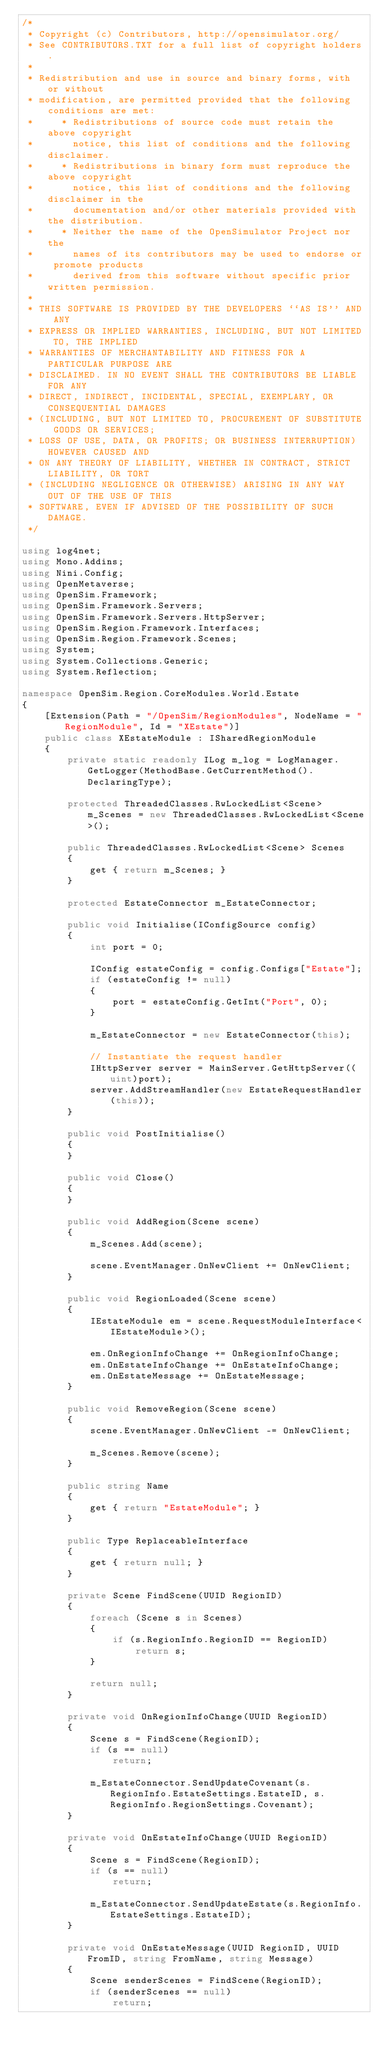<code> <loc_0><loc_0><loc_500><loc_500><_C#_>/*
 * Copyright (c) Contributors, http://opensimulator.org/
 * See CONTRIBUTORS.TXT for a full list of copyright holders.
 *
 * Redistribution and use in source and binary forms, with or without
 * modification, are permitted provided that the following conditions are met:
 *     * Redistributions of source code must retain the above copyright
 *       notice, this list of conditions and the following disclaimer.
 *     * Redistributions in binary form must reproduce the above copyright
 *       notice, this list of conditions and the following disclaimer in the
 *       documentation and/or other materials provided with the distribution.
 *     * Neither the name of the OpenSimulator Project nor the
 *       names of its contributors may be used to endorse or promote products
 *       derived from this software without specific prior written permission.
 *
 * THIS SOFTWARE IS PROVIDED BY THE DEVELOPERS ``AS IS'' AND ANY
 * EXPRESS OR IMPLIED WARRANTIES, INCLUDING, BUT NOT LIMITED TO, THE IMPLIED
 * WARRANTIES OF MERCHANTABILITY AND FITNESS FOR A PARTICULAR PURPOSE ARE
 * DISCLAIMED. IN NO EVENT SHALL THE CONTRIBUTORS BE LIABLE FOR ANY
 * DIRECT, INDIRECT, INCIDENTAL, SPECIAL, EXEMPLARY, OR CONSEQUENTIAL DAMAGES
 * (INCLUDING, BUT NOT LIMITED TO, PROCUREMENT OF SUBSTITUTE GOODS OR SERVICES;
 * LOSS OF USE, DATA, OR PROFITS; OR BUSINESS INTERRUPTION) HOWEVER CAUSED AND
 * ON ANY THEORY OF LIABILITY, WHETHER IN CONTRACT, STRICT LIABILITY, OR TORT
 * (INCLUDING NEGLIGENCE OR OTHERWISE) ARISING IN ANY WAY OUT OF THE USE OF THIS
 * SOFTWARE, EVEN IF ADVISED OF THE POSSIBILITY OF SUCH DAMAGE.
 */

using log4net;
using Mono.Addins;
using Nini.Config;
using OpenMetaverse;
using OpenSim.Framework;
using OpenSim.Framework.Servers;
using OpenSim.Framework.Servers.HttpServer;
using OpenSim.Region.Framework.Interfaces;
using OpenSim.Region.Framework.Scenes;
using System;
using System.Collections.Generic;
using System.Reflection;

namespace OpenSim.Region.CoreModules.World.Estate
{
    [Extension(Path = "/OpenSim/RegionModules", NodeName = "RegionModule", Id = "XEstate")]
    public class XEstateModule : ISharedRegionModule
    {
        private static readonly ILog m_log = LogManager.GetLogger(MethodBase.GetCurrentMethod().DeclaringType);

        protected ThreadedClasses.RwLockedList<Scene> m_Scenes = new ThreadedClasses.RwLockedList<Scene>();

        public ThreadedClasses.RwLockedList<Scene> Scenes
        {
            get { return m_Scenes; }
        }

        protected EstateConnector m_EstateConnector;

        public void Initialise(IConfigSource config)
        {
            int port = 0;

            IConfig estateConfig = config.Configs["Estate"];
            if (estateConfig != null)
            {
                port = estateConfig.GetInt("Port", 0);
            }

            m_EstateConnector = new EstateConnector(this);

            // Instantiate the request handler
            IHttpServer server = MainServer.GetHttpServer((uint)port);
            server.AddStreamHandler(new EstateRequestHandler(this));
        }

        public void PostInitialise()
        {
        }

        public void Close()
        {
        }

        public void AddRegion(Scene scene)
        {
            m_Scenes.Add(scene);

            scene.EventManager.OnNewClient += OnNewClient;
        }

        public void RegionLoaded(Scene scene)
        {
            IEstateModule em = scene.RequestModuleInterface<IEstateModule>();

            em.OnRegionInfoChange += OnRegionInfoChange;
            em.OnEstateInfoChange += OnEstateInfoChange;
            em.OnEstateMessage += OnEstateMessage;
        }

        public void RemoveRegion(Scene scene)
        {
            scene.EventManager.OnNewClient -= OnNewClient;

            m_Scenes.Remove(scene);
        }

        public string Name
        {
            get { return "EstateModule"; }
        }

        public Type ReplaceableInterface
        {
            get { return null; }
        }

        private Scene FindScene(UUID RegionID)
        {
            foreach (Scene s in Scenes)
            {
                if (s.RegionInfo.RegionID == RegionID)
                    return s;
            }

            return null;
        }

        private void OnRegionInfoChange(UUID RegionID)
        {
            Scene s = FindScene(RegionID);
            if (s == null)
                return;

            m_EstateConnector.SendUpdateCovenant(s.RegionInfo.EstateSettings.EstateID, s.RegionInfo.RegionSettings.Covenant);
        }

        private void OnEstateInfoChange(UUID RegionID)
        {
            Scene s = FindScene(RegionID);
            if (s == null)
                return;

            m_EstateConnector.SendUpdateEstate(s.RegionInfo.EstateSettings.EstateID);
        }

        private void OnEstateMessage(UUID RegionID, UUID FromID, string FromName, string Message)
        {
            Scene senderScenes = FindScene(RegionID);
            if (senderScenes == null)
                return;
</code> 